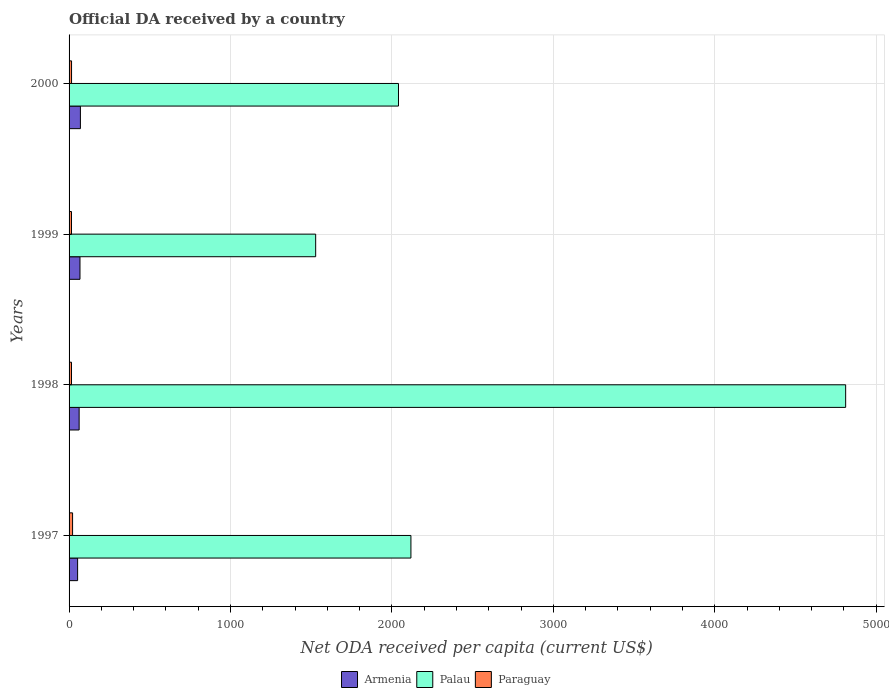How many groups of bars are there?
Keep it short and to the point. 4. Are the number of bars per tick equal to the number of legend labels?
Give a very brief answer. Yes. Are the number of bars on each tick of the Y-axis equal?
Offer a very short reply. Yes. How many bars are there on the 4th tick from the bottom?
Offer a terse response. 3. What is the ODA received in in Paraguay in 1997?
Make the answer very short. 21.71. Across all years, what is the maximum ODA received in in Paraguay?
Your response must be concise. 21.71. Across all years, what is the minimum ODA received in in Armenia?
Provide a succinct answer. 52.94. In which year was the ODA received in in Armenia maximum?
Your answer should be very brief. 2000. What is the total ODA received in in Palau in the graph?
Offer a terse response. 1.05e+04. What is the difference between the ODA received in in Paraguay in 1997 and that in 2000?
Give a very brief answer. 6.33. What is the difference between the ODA received in in Palau in 2000 and the ODA received in in Paraguay in 1997?
Ensure brevity in your answer.  2019.07. What is the average ODA received in in Palau per year?
Offer a terse response. 2624.32. In the year 2000, what is the difference between the ODA received in in Paraguay and ODA received in in Armenia?
Offer a very short reply. -54.8. In how many years, is the ODA received in in Armenia greater than 4200 US$?
Your response must be concise. 0. What is the ratio of the ODA received in in Paraguay in 1997 to that in 2000?
Give a very brief answer. 1.41. Is the difference between the ODA received in in Paraguay in 1999 and 2000 greater than the difference between the ODA received in in Armenia in 1999 and 2000?
Your response must be concise. Yes. What is the difference between the highest and the second highest ODA received in in Armenia?
Provide a short and direct response. 2.57. What is the difference between the highest and the lowest ODA received in in Armenia?
Provide a short and direct response. 17.25. What does the 1st bar from the top in 1999 represents?
Make the answer very short. Paraguay. What does the 3rd bar from the bottom in 1997 represents?
Make the answer very short. Paraguay. How many years are there in the graph?
Keep it short and to the point. 4. What is the difference between two consecutive major ticks on the X-axis?
Ensure brevity in your answer.  1000. Are the values on the major ticks of X-axis written in scientific E-notation?
Make the answer very short. No. How are the legend labels stacked?
Your answer should be compact. Horizontal. What is the title of the graph?
Provide a short and direct response. Official DA received by a country. What is the label or title of the X-axis?
Give a very brief answer. Net ODA received per capita (current US$). What is the Net ODA received per capita (current US$) of Armenia in 1997?
Your response must be concise. 52.94. What is the Net ODA received per capita (current US$) of Palau in 1997?
Your answer should be compact. 2117.75. What is the Net ODA received per capita (current US$) of Paraguay in 1997?
Keep it short and to the point. 21.71. What is the Net ODA received per capita (current US$) of Armenia in 1998?
Provide a short and direct response. 62.38. What is the Net ODA received per capita (current US$) in Palau in 1998?
Your answer should be very brief. 4811.06. What is the Net ODA received per capita (current US$) of Paraguay in 1998?
Offer a terse response. 15.06. What is the Net ODA received per capita (current US$) of Armenia in 1999?
Provide a succinct answer. 67.61. What is the Net ODA received per capita (current US$) of Palau in 1999?
Provide a short and direct response. 1527.7. What is the Net ODA received per capita (current US$) of Paraguay in 1999?
Make the answer very short. 15.02. What is the Net ODA received per capita (current US$) of Armenia in 2000?
Offer a terse response. 70.18. What is the Net ODA received per capita (current US$) in Palau in 2000?
Keep it short and to the point. 2040.78. What is the Net ODA received per capita (current US$) in Paraguay in 2000?
Offer a terse response. 15.38. Across all years, what is the maximum Net ODA received per capita (current US$) of Armenia?
Provide a short and direct response. 70.18. Across all years, what is the maximum Net ODA received per capita (current US$) of Palau?
Make the answer very short. 4811.06. Across all years, what is the maximum Net ODA received per capita (current US$) in Paraguay?
Your answer should be compact. 21.71. Across all years, what is the minimum Net ODA received per capita (current US$) of Armenia?
Keep it short and to the point. 52.94. Across all years, what is the minimum Net ODA received per capita (current US$) in Palau?
Your response must be concise. 1527.7. Across all years, what is the minimum Net ODA received per capita (current US$) in Paraguay?
Your answer should be compact. 15.02. What is the total Net ODA received per capita (current US$) of Armenia in the graph?
Give a very brief answer. 253.12. What is the total Net ODA received per capita (current US$) of Palau in the graph?
Keep it short and to the point. 1.05e+04. What is the total Net ODA received per capita (current US$) of Paraguay in the graph?
Your response must be concise. 67.18. What is the difference between the Net ODA received per capita (current US$) in Armenia in 1997 and that in 1998?
Your answer should be very brief. -9.45. What is the difference between the Net ODA received per capita (current US$) in Palau in 1997 and that in 1998?
Make the answer very short. -2693.3. What is the difference between the Net ODA received per capita (current US$) of Paraguay in 1997 and that in 1998?
Give a very brief answer. 6.65. What is the difference between the Net ODA received per capita (current US$) of Armenia in 1997 and that in 1999?
Give a very brief answer. -14.67. What is the difference between the Net ODA received per capita (current US$) of Palau in 1997 and that in 1999?
Ensure brevity in your answer.  590.05. What is the difference between the Net ODA received per capita (current US$) in Paraguay in 1997 and that in 1999?
Offer a terse response. 6.69. What is the difference between the Net ODA received per capita (current US$) of Armenia in 1997 and that in 2000?
Your answer should be very brief. -17.25. What is the difference between the Net ODA received per capita (current US$) of Palau in 1997 and that in 2000?
Your answer should be very brief. 76.97. What is the difference between the Net ODA received per capita (current US$) in Paraguay in 1997 and that in 2000?
Make the answer very short. 6.33. What is the difference between the Net ODA received per capita (current US$) of Armenia in 1998 and that in 1999?
Your response must be concise. -5.23. What is the difference between the Net ODA received per capita (current US$) of Palau in 1998 and that in 1999?
Offer a very short reply. 3283.35. What is the difference between the Net ODA received per capita (current US$) of Paraguay in 1998 and that in 1999?
Provide a succinct answer. 0.04. What is the difference between the Net ODA received per capita (current US$) in Armenia in 1998 and that in 2000?
Provide a short and direct response. -7.8. What is the difference between the Net ODA received per capita (current US$) in Palau in 1998 and that in 2000?
Your answer should be compact. 2770.27. What is the difference between the Net ODA received per capita (current US$) of Paraguay in 1998 and that in 2000?
Provide a short and direct response. -0.31. What is the difference between the Net ODA received per capita (current US$) in Armenia in 1999 and that in 2000?
Offer a very short reply. -2.57. What is the difference between the Net ODA received per capita (current US$) of Palau in 1999 and that in 2000?
Your answer should be compact. -513.08. What is the difference between the Net ODA received per capita (current US$) in Paraguay in 1999 and that in 2000?
Your response must be concise. -0.36. What is the difference between the Net ODA received per capita (current US$) in Armenia in 1997 and the Net ODA received per capita (current US$) in Palau in 1998?
Provide a short and direct response. -4758.12. What is the difference between the Net ODA received per capita (current US$) of Armenia in 1997 and the Net ODA received per capita (current US$) of Paraguay in 1998?
Offer a terse response. 37.87. What is the difference between the Net ODA received per capita (current US$) in Palau in 1997 and the Net ODA received per capita (current US$) in Paraguay in 1998?
Your response must be concise. 2102.69. What is the difference between the Net ODA received per capita (current US$) in Armenia in 1997 and the Net ODA received per capita (current US$) in Palau in 1999?
Offer a terse response. -1474.77. What is the difference between the Net ODA received per capita (current US$) in Armenia in 1997 and the Net ODA received per capita (current US$) in Paraguay in 1999?
Provide a short and direct response. 37.92. What is the difference between the Net ODA received per capita (current US$) of Palau in 1997 and the Net ODA received per capita (current US$) of Paraguay in 1999?
Offer a very short reply. 2102.73. What is the difference between the Net ODA received per capita (current US$) of Armenia in 1997 and the Net ODA received per capita (current US$) of Palau in 2000?
Keep it short and to the point. -1987.85. What is the difference between the Net ODA received per capita (current US$) in Armenia in 1997 and the Net ODA received per capita (current US$) in Paraguay in 2000?
Your answer should be compact. 37.56. What is the difference between the Net ODA received per capita (current US$) in Palau in 1997 and the Net ODA received per capita (current US$) in Paraguay in 2000?
Give a very brief answer. 2102.37. What is the difference between the Net ODA received per capita (current US$) of Armenia in 1998 and the Net ODA received per capita (current US$) of Palau in 1999?
Offer a very short reply. -1465.32. What is the difference between the Net ODA received per capita (current US$) of Armenia in 1998 and the Net ODA received per capita (current US$) of Paraguay in 1999?
Give a very brief answer. 47.36. What is the difference between the Net ODA received per capita (current US$) of Palau in 1998 and the Net ODA received per capita (current US$) of Paraguay in 1999?
Offer a terse response. 4796.04. What is the difference between the Net ODA received per capita (current US$) in Armenia in 1998 and the Net ODA received per capita (current US$) in Palau in 2000?
Provide a short and direct response. -1978.4. What is the difference between the Net ODA received per capita (current US$) of Armenia in 1998 and the Net ODA received per capita (current US$) of Paraguay in 2000?
Ensure brevity in your answer.  47.01. What is the difference between the Net ODA received per capita (current US$) of Palau in 1998 and the Net ODA received per capita (current US$) of Paraguay in 2000?
Your response must be concise. 4795.68. What is the difference between the Net ODA received per capita (current US$) in Armenia in 1999 and the Net ODA received per capita (current US$) in Palau in 2000?
Make the answer very short. -1973.17. What is the difference between the Net ODA received per capita (current US$) of Armenia in 1999 and the Net ODA received per capita (current US$) of Paraguay in 2000?
Give a very brief answer. 52.23. What is the difference between the Net ODA received per capita (current US$) in Palau in 1999 and the Net ODA received per capita (current US$) in Paraguay in 2000?
Provide a succinct answer. 1512.33. What is the average Net ODA received per capita (current US$) in Armenia per year?
Provide a succinct answer. 63.28. What is the average Net ODA received per capita (current US$) in Palau per year?
Offer a very short reply. 2624.32. What is the average Net ODA received per capita (current US$) of Paraguay per year?
Offer a terse response. 16.79. In the year 1997, what is the difference between the Net ODA received per capita (current US$) of Armenia and Net ODA received per capita (current US$) of Palau?
Offer a terse response. -2064.81. In the year 1997, what is the difference between the Net ODA received per capita (current US$) in Armenia and Net ODA received per capita (current US$) in Paraguay?
Provide a short and direct response. 31.22. In the year 1997, what is the difference between the Net ODA received per capita (current US$) in Palau and Net ODA received per capita (current US$) in Paraguay?
Keep it short and to the point. 2096.04. In the year 1998, what is the difference between the Net ODA received per capita (current US$) in Armenia and Net ODA received per capita (current US$) in Palau?
Ensure brevity in your answer.  -4748.67. In the year 1998, what is the difference between the Net ODA received per capita (current US$) in Armenia and Net ODA received per capita (current US$) in Paraguay?
Provide a short and direct response. 47.32. In the year 1998, what is the difference between the Net ODA received per capita (current US$) of Palau and Net ODA received per capita (current US$) of Paraguay?
Give a very brief answer. 4795.99. In the year 1999, what is the difference between the Net ODA received per capita (current US$) in Armenia and Net ODA received per capita (current US$) in Palau?
Your answer should be very brief. -1460.09. In the year 1999, what is the difference between the Net ODA received per capita (current US$) of Armenia and Net ODA received per capita (current US$) of Paraguay?
Your answer should be compact. 52.59. In the year 1999, what is the difference between the Net ODA received per capita (current US$) of Palau and Net ODA received per capita (current US$) of Paraguay?
Your answer should be very brief. 1512.68. In the year 2000, what is the difference between the Net ODA received per capita (current US$) of Armenia and Net ODA received per capita (current US$) of Palau?
Offer a very short reply. -1970.6. In the year 2000, what is the difference between the Net ODA received per capita (current US$) of Armenia and Net ODA received per capita (current US$) of Paraguay?
Make the answer very short. 54.8. In the year 2000, what is the difference between the Net ODA received per capita (current US$) in Palau and Net ODA received per capita (current US$) in Paraguay?
Keep it short and to the point. 2025.41. What is the ratio of the Net ODA received per capita (current US$) of Armenia in 1997 to that in 1998?
Keep it short and to the point. 0.85. What is the ratio of the Net ODA received per capita (current US$) of Palau in 1997 to that in 1998?
Offer a terse response. 0.44. What is the ratio of the Net ODA received per capita (current US$) in Paraguay in 1997 to that in 1998?
Your response must be concise. 1.44. What is the ratio of the Net ODA received per capita (current US$) in Armenia in 1997 to that in 1999?
Your response must be concise. 0.78. What is the ratio of the Net ODA received per capita (current US$) of Palau in 1997 to that in 1999?
Offer a very short reply. 1.39. What is the ratio of the Net ODA received per capita (current US$) of Paraguay in 1997 to that in 1999?
Your answer should be very brief. 1.45. What is the ratio of the Net ODA received per capita (current US$) of Armenia in 1997 to that in 2000?
Ensure brevity in your answer.  0.75. What is the ratio of the Net ODA received per capita (current US$) in Palau in 1997 to that in 2000?
Provide a short and direct response. 1.04. What is the ratio of the Net ODA received per capita (current US$) in Paraguay in 1997 to that in 2000?
Keep it short and to the point. 1.41. What is the ratio of the Net ODA received per capita (current US$) in Armenia in 1998 to that in 1999?
Your answer should be compact. 0.92. What is the ratio of the Net ODA received per capita (current US$) of Palau in 1998 to that in 1999?
Keep it short and to the point. 3.15. What is the ratio of the Net ODA received per capita (current US$) in Armenia in 1998 to that in 2000?
Provide a succinct answer. 0.89. What is the ratio of the Net ODA received per capita (current US$) of Palau in 1998 to that in 2000?
Ensure brevity in your answer.  2.36. What is the ratio of the Net ODA received per capita (current US$) of Paraguay in 1998 to that in 2000?
Your answer should be very brief. 0.98. What is the ratio of the Net ODA received per capita (current US$) in Armenia in 1999 to that in 2000?
Give a very brief answer. 0.96. What is the ratio of the Net ODA received per capita (current US$) in Palau in 1999 to that in 2000?
Keep it short and to the point. 0.75. What is the ratio of the Net ODA received per capita (current US$) in Paraguay in 1999 to that in 2000?
Offer a very short reply. 0.98. What is the difference between the highest and the second highest Net ODA received per capita (current US$) of Armenia?
Ensure brevity in your answer.  2.57. What is the difference between the highest and the second highest Net ODA received per capita (current US$) in Palau?
Offer a terse response. 2693.3. What is the difference between the highest and the second highest Net ODA received per capita (current US$) in Paraguay?
Provide a short and direct response. 6.33. What is the difference between the highest and the lowest Net ODA received per capita (current US$) in Armenia?
Your response must be concise. 17.25. What is the difference between the highest and the lowest Net ODA received per capita (current US$) of Palau?
Make the answer very short. 3283.35. What is the difference between the highest and the lowest Net ODA received per capita (current US$) of Paraguay?
Your answer should be very brief. 6.69. 